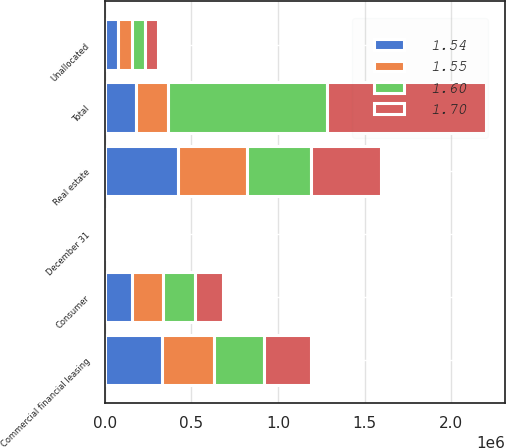Convert chart to OTSL. <chart><loc_0><loc_0><loc_500><loc_500><stacked_bar_chart><ecel><fcel>December 31<fcel>Commercial financial leasing<fcel>Real estate<fcel>Consumer<fcel>Unallocated<fcel>Total<nl><fcel>1.54<fcel>2016<fcel>330833<fcel>423846<fcel>156288<fcel>78030<fcel>182176<nl><fcel>1.55<fcel>2015<fcel>300404<fcel>399069<fcel>178320<fcel>78199<fcel>182176<nl><fcel>1.6<fcel>2014<fcel>288038<fcel>369837<fcel>186033<fcel>75654<fcel>919562<nl><fcel>1.7<fcel>2013<fcel>273383<fcel>403634<fcel>164644<fcel>75015<fcel>916676<nl></chart> 